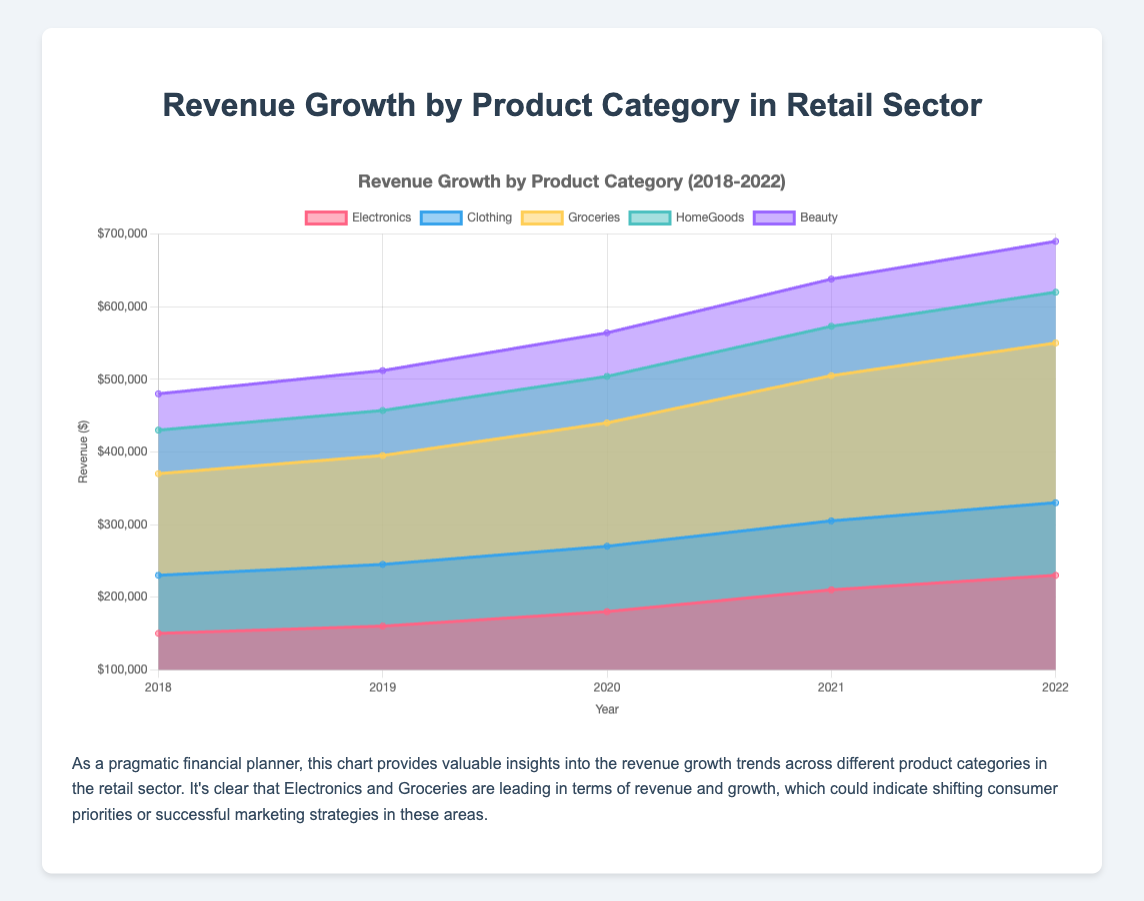What is the title of the chart? The title of the chart is located at the top and reads "Revenue Growth by Product Category (2018-2022)."
Answer: Revenue Growth by Product Category (2018-2022) Which product category had the highest revenue in 2022? By looking at the data points on the chart for the year 2022, the category with the highest revenue is the one with the highest point. Electronics has the highest point in 2022.
Answer: Electronics How did the revenue for the Beauty category change from 2018 to 2022? Locate the Beauty category's data points for 2018 and 2022. In 2018, the revenue was $50,000, and in 2022, it was $70,000. The revenue increased by $20,000.
Answer: Increased by $20,000 Which year saw the largest increase in revenue for the Groceries category? Compare the revenue for the Groceries category year by year. The largest increase is from 2019 to 2020, where the revenue rose from $150,000 to $170,000.
Answer: 2020 Compare the revenue of Electronics and HomeGoods in 2021. Which one was higher? Look at the data points for Electronics and HomeGoods in 2021. Electronics had a revenue of $210,000, and HomeGoods had $68,000. Electronics had higher revenue.
Answer: Electronics Calculate the total revenue for all categories combined in 2019. Sum up the revenue for all categories in 2019: $160,000 (Electronics) + $85,000 (Clothing) + $150,000 (Groceries) + $62,000 (HomeGoods) + $55,000 (Beauty) = $512,000.
Answer: $512,000 Which category showed the most consistent growth over the years? Look for the category with consistent increases year over year. The Beauty category shows steady growth from $50,000 in 2018 up to $70,000 in 2022.
Answer: Beauty What is the average revenue for the Clothing category from 2018 to 2022? Calculate the total revenue for Clothing from 2018 to 2022 and divide by the number of years: ($80,000 + $85,000 + $90,000 + $95,000 + $100,000) / 5 = $90,000.
Answer: $90,000 Which year had the least revenue growth for HomeGoods? Compare the revenue for HomeGoods year by year to find the smallest increase: The smallest increase is from 2021 to 2022, with growth from $68,000 to $70,000, an increase of $2,000.
Answer: 2022 